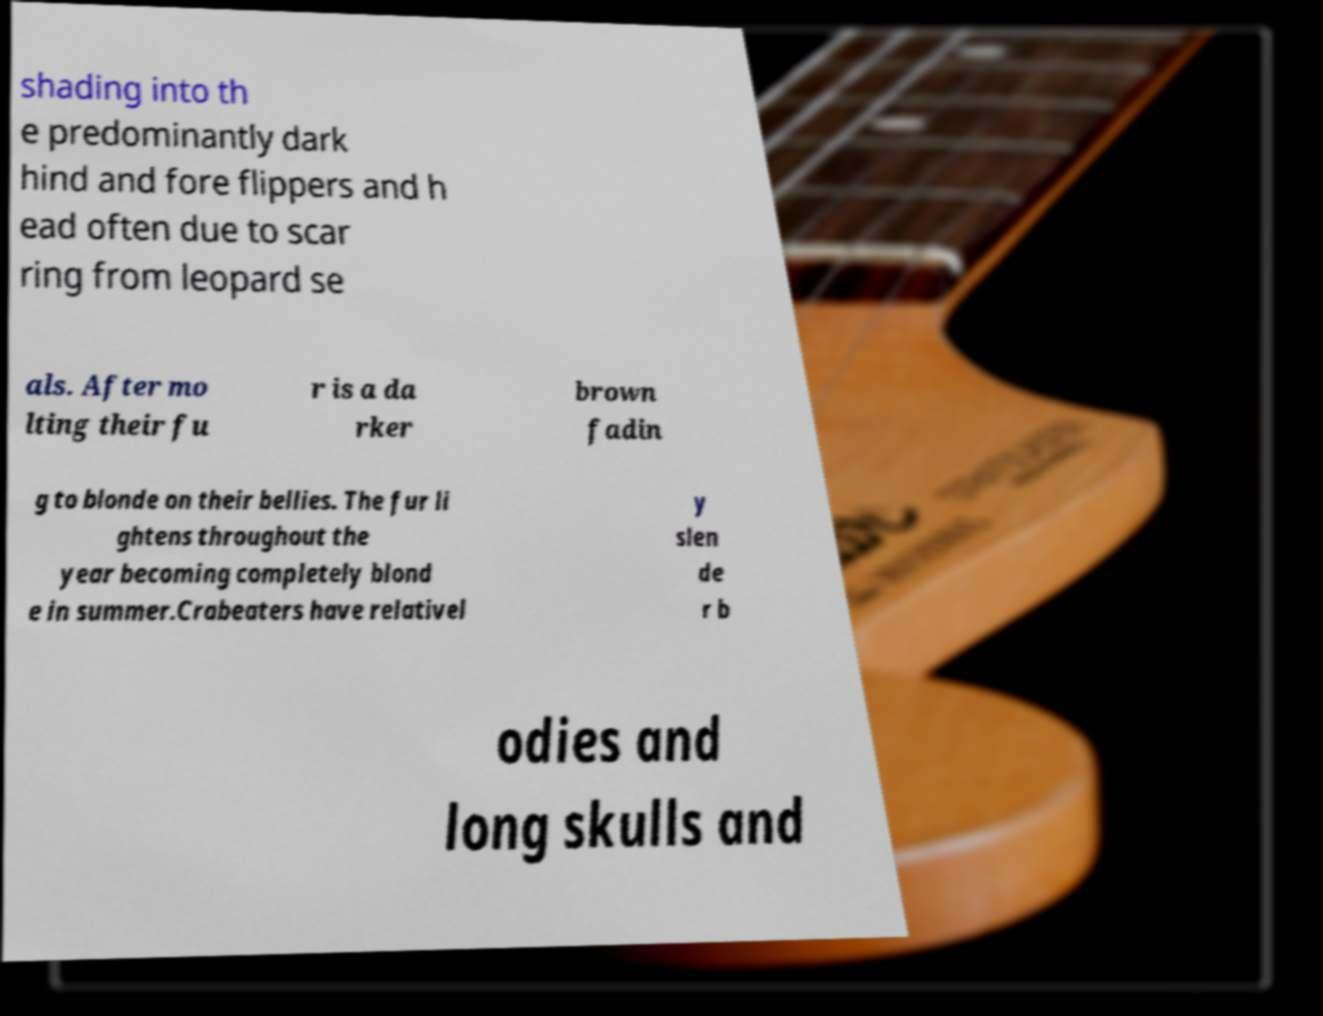Can you read and provide the text displayed in the image?This photo seems to have some interesting text. Can you extract and type it out for me? shading into th e predominantly dark hind and fore flippers and h ead often due to scar ring from leopard se als. After mo lting their fu r is a da rker brown fadin g to blonde on their bellies. The fur li ghtens throughout the year becoming completely blond e in summer.Crabeaters have relativel y slen de r b odies and long skulls and 